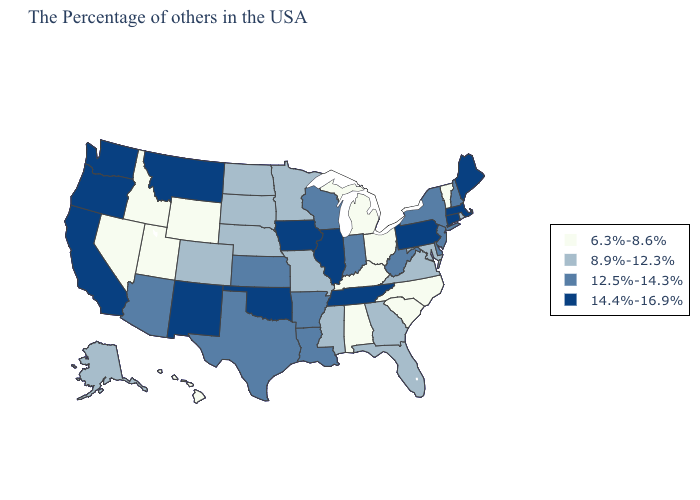Name the states that have a value in the range 6.3%-8.6%?
Short answer required. Vermont, North Carolina, South Carolina, Ohio, Michigan, Kentucky, Alabama, Wyoming, Utah, Idaho, Nevada, Hawaii. Does Pennsylvania have the same value as Oklahoma?
Quick response, please. Yes. What is the value of Michigan?
Short answer required. 6.3%-8.6%. What is the lowest value in the South?
Quick response, please. 6.3%-8.6%. Does Oklahoma have the highest value in the South?
Quick response, please. Yes. Does South Carolina have the highest value in the USA?
Write a very short answer. No. Among the states that border Florida , which have the highest value?
Answer briefly. Georgia. Among the states that border South Dakota , does Wyoming have the lowest value?
Write a very short answer. Yes. Name the states that have a value in the range 8.9%-12.3%?
Give a very brief answer. Rhode Island, Maryland, Virginia, Florida, Georgia, Mississippi, Missouri, Minnesota, Nebraska, South Dakota, North Dakota, Colorado, Alaska. Name the states that have a value in the range 8.9%-12.3%?
Short answer required. Rhode Island, Maryland, Virginia, Florida, Georgia, Mississippi, Missouri, Minnesota, Nebraska, South Dakota, North Dakota, Colorado, Alaska. What is the lowest value in states that border Virginia?
Give a very brief answer. 6.3%-8.6%. Is the legend a continuous bar?
Short answer required. No. Does Louisiana have the highest value in the USA?
Concise answer only. No. What is the lowest value in states that border Washington?
Quick response, please. 6.3%-8.6%. Does Iowa have a lower value than Alabama?
Quick response, please. No. 